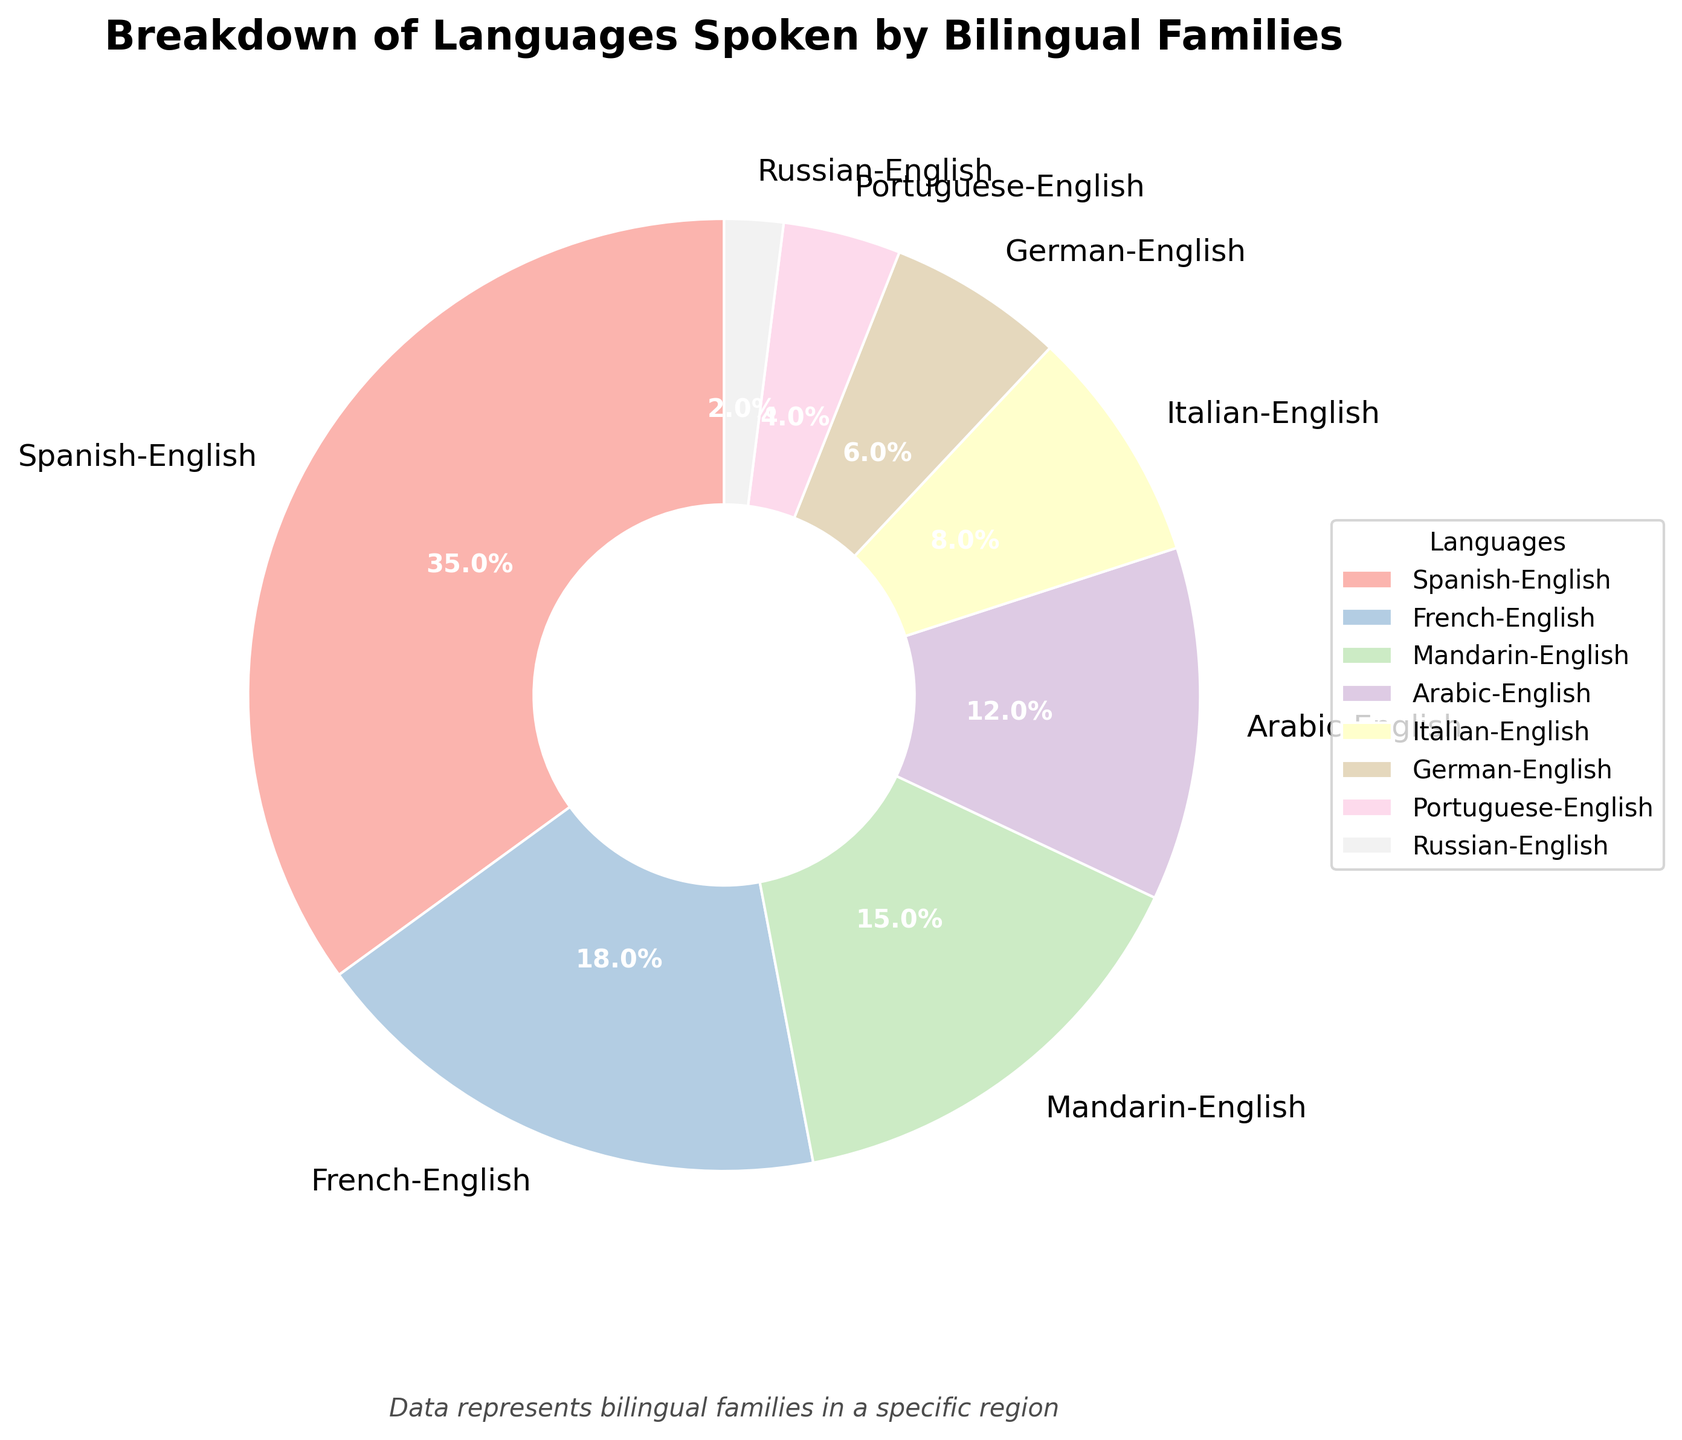What is the most common language spoken by bilingual families in this region? The largest section of the pie chart corresponds to Spanish-English, shown at 35%. This means Spanish-English is the most common language combination spoken by bilingual families in this region.
Answer: Spanish-English Which language combination is the least common among bilingual families according to the pie chart? The smallest section of the pie chart corresponds to Russian-English, shown at 2%. This means Russian-English is the least common language combination among bilingual families in this region.
Answer: Russian-English How many percentage points more common is French-English compared to German-English? To find how many percentage points more common French-English is compared to German-English, subtract the percentage for German-English from the percentage for French-English: 18% - 6% = 12%.
Answer: 12 percentage points What is the combined percentage of the top two most commonly spoken language pairs? The top two most commonly spoken language pairs are Spanish-English at 35% and French-English at 18%. Adding these percentages gives 35% + 18% = 53%.
Answer: 53% Which language combination is more commonly spoken: Mandarin-English or Arabic-English, and by how many percentage points? Mandarin-English is shown at 15% and Arabic-English at 12%. Therefore, Mandarin-English is more commonly spoken. The difference is 15% - 12% = 3 percentage points.
Answer: Mandarin-English by 3 percentage points Do Italian-English and German-English collectively account for more or less than 15%? Adding the percentages for Italian-English and German-English gives 8% + 6% = 14%, which is less than 15%.
Answer: Less than 15% How does the percentage of Portuguese-English compare to Mandarin-English in the pie chart? Mandarin-English is shown at 15%, while Portuguese-English is shown at 4%. Since 15% is greater than 4%, Mandarin-English is more common.
Answer: Mandarin-English is more common What percentage of bilingual families speak a language combination other than the top three most common combinations? The top three most common combinations are Spanish-English (35%), French-English (18%), and Mandarin-English (15%). Adding these gives 35% + 18% + 15% = 68%. The remaining percentage is 100% - 68% = 32%.
Answer: 32% If you combined the percentages for Arabic-English and Italian-English, would it surpass French-English? Adding the percentages for Arabic-English and Italian-English gives 12% + 8% = 20%, which is greater than French-English at 18%.
Answer: Yes By what factor is the percentage of Spanish-English greater than Russian-English? The percentage of Spanish-English is 35%, and Russian-English is 2%. The factor is calculated as 35 / 2 = 17.5.
Answer: 17.5 